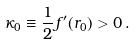Convert formula to latex. <formula><loc_0><loc_0><loc_500><loc_500>\kappa _ { 0 } \equiv \frac { 1 } { 2 } f ^ { \prime } ( r _ { 0 } ) > 0 \, .</formula> 